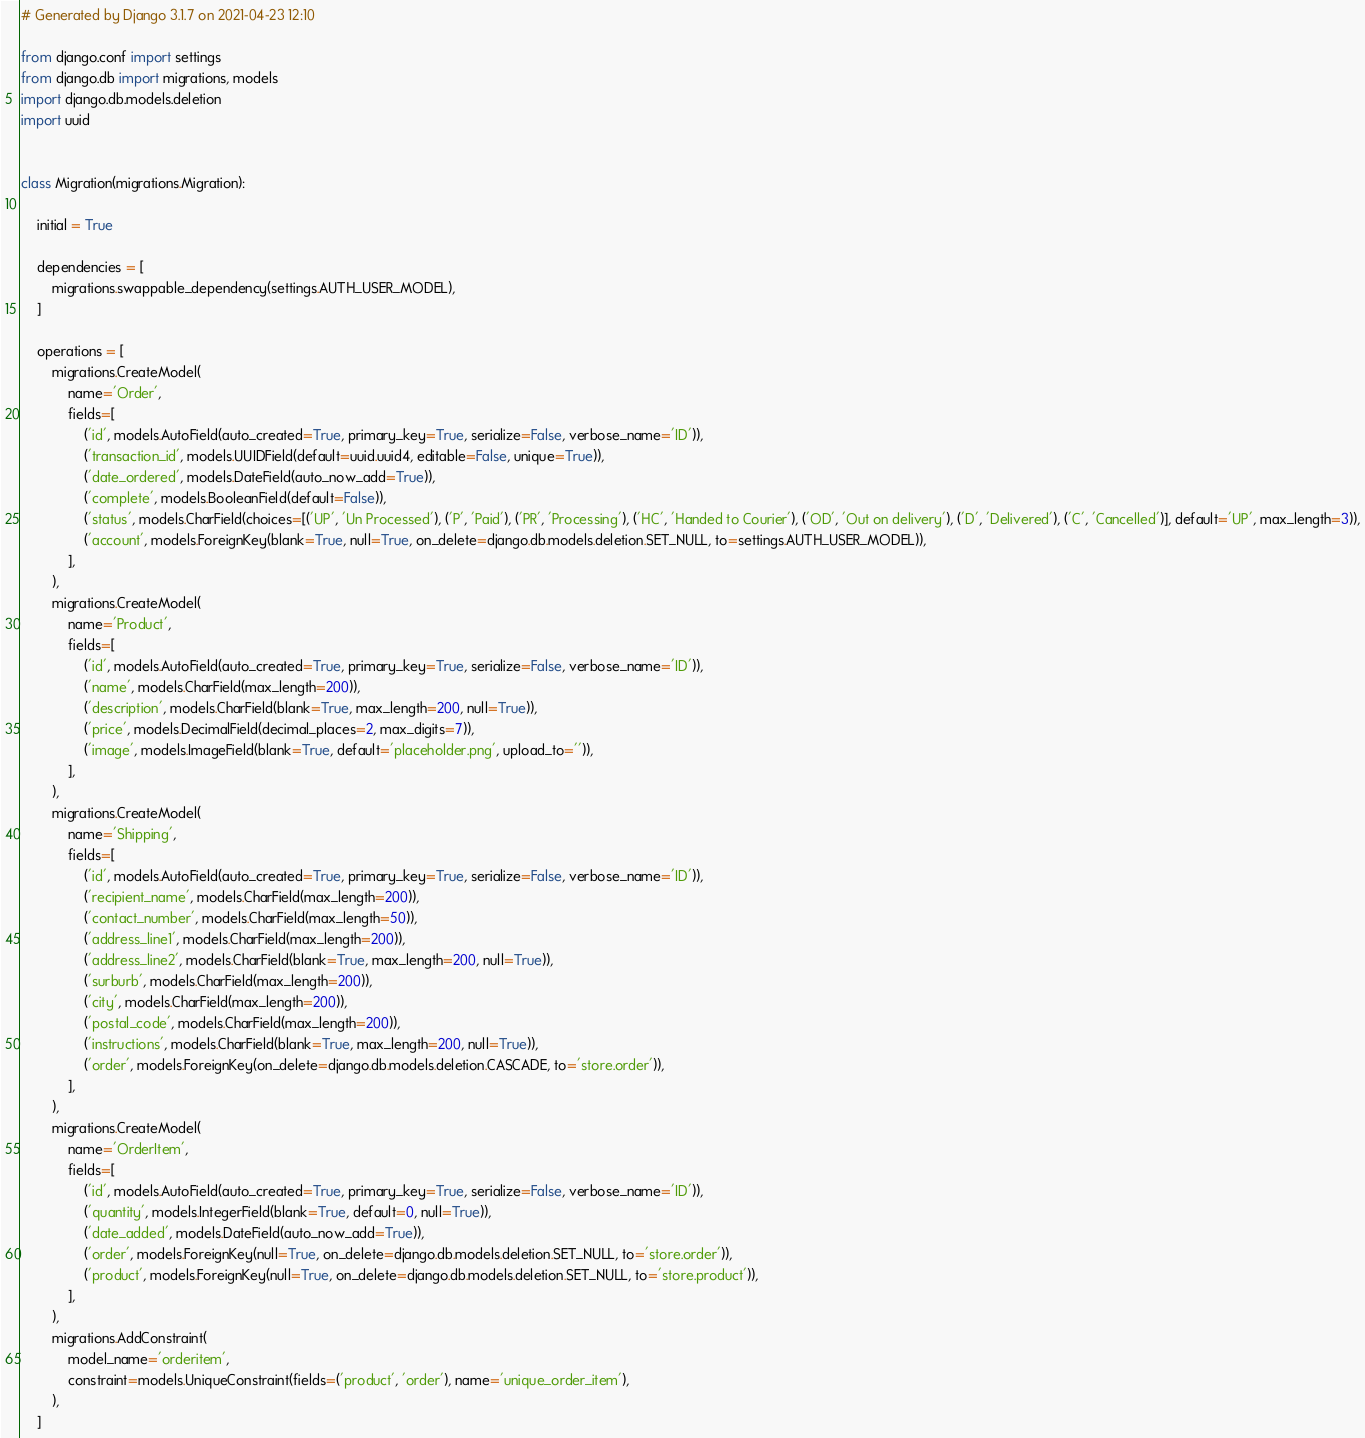Convert code to text. <code><loc_0><loc_0><loc_500><loc_500><_Python_># Generated by Django 3.1.7 on 2021-04-23 12:10

from django.conf import settings
from django.db import migrations, models
import django.db.models.deletion
import uuid


class Migration(migrations.Migration):

    initial = True

    dependencies = [
        migrations.swappable_dependency(settings.AUTH_USER_MODEL),
    ]

    operations = [
        migrations.CreateModel(
            name='Order',
            fields=[
                ('id', models.AutoField(auto_created=True, primary_key=True, serialize=False, verbose_name='ID')),
                ('transaction_id', models.UUIDField(default=uuid.uuid4, editable=False, unique=True)),
                ('date_ordered', models.DateField(auto_now_add=True)),
                ('complete', models.BooleanField(default=False)),
                ('status', models.CharField(choices=[('UP', 'Un Processed'), ('P', 'Paid'), ('PR', 'Processing'), ('HC', 'Handed to Courier'), ('OD', 'Out on delivery'), ('D', 'Delivered'), ('C', 'Cancelled')], default='UP', max_length=3)),
                ('account', models.ForeignKey(blank=True, null=True, on_delete=django.db.models.deletion.SET_NULL, to=settings.AUTH_USER_MODEL)),
            ],
        ),
        migrations.CreateModel(
            name='Product',
            fields=[
                ('id', models.AutoField(auto_created=True, primary_key=True, serialize=False, verbose_name='ID')),
                ('name', models.CharField(max_length=200)),
                ('description', models.CharField(blank=True, max_length=200, null=True)),
                ('price', models.DecimalField(decimal_places=2, max_digits=7)),
                ('image', models.ImageField(blank=True, default='placeholder.png', upload_to='')),
            ],
        ),
        migrations.CreateModel(
            name='Shipping',
            fields=[
                ('id', models.AutoField(auto_created=True, primary_key=True, serialize=False, verbose_name='ID')),
                ('recipient_name', models.CharField(max_length=200)),
                ('contact_number', models.CharField(max_length=50)),
                ('address_line1', models.CharField(max_length=200)),
                ('address_line2', models.CharField(blank=True, max_length=200, null=True)),
                ('surburb', models.CharField(max_length=200)),
                ('city', models.CharField(max_length=200)),
                ('postal_code', models.CharField(max_length=200)),
                ('instructions', models.CharField(blank=True, max_length=200, null=True)),
                ('order', models.ForeignKey(on_delete=django.db.models.deletion.CASCADE, to='store.order')),
            ],
        ),
        migrations.CreateModel(
            name='OrderItem',
            fields=[
                ('id', models.AutoField(auto_created=True, primary_key=True, serialize=False, verbose_name='ID')),
                ('quantity', models.IntegerField(blank=True, default=0, null=True)),
                ('date_added', models.DateField(auto_now_add=True)),
                ('order', models.ForeignKey(null=True, on_delete=django.db.models.deletion.SET_NULL, to='store.order')),
                ('product', models.ForeignKey(null=True, on_delete=django.db.models.deletion.SET_NULL, to='store.product')),
            ],
        ),
        migrations.AddConstraint(
            model_name='orderitem',
            constraint=models.UniqueConstraint(fields=('product', 'order'), name='unique_order_item'),
        ),
    ]
</code> 